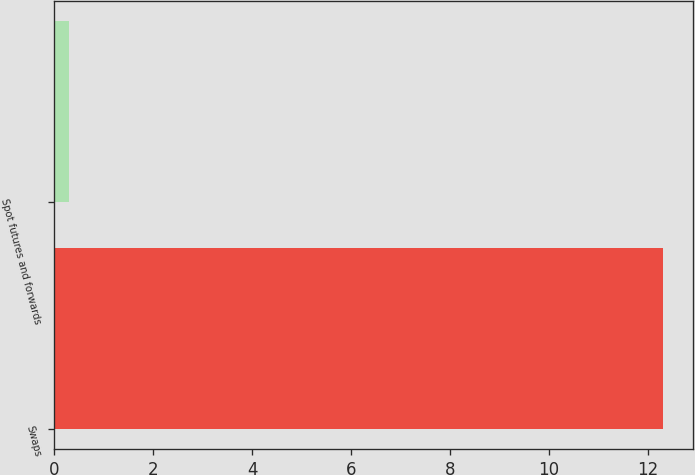Convert chart. <chart><loc_0><loc_0><loc_500><loc_500><bar_chart><fcel>Swaps<fcel>Spot futures and forwards<nl><fcel>12.3<fcel>0.3<nl></chart> 